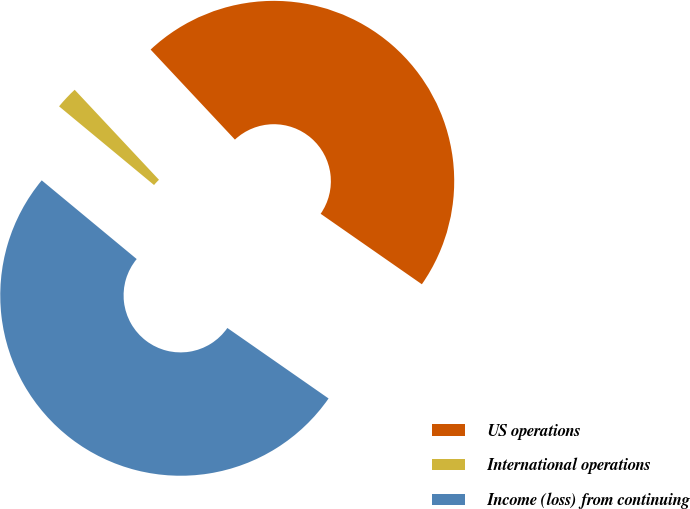<chart> <loc_0><loc_0><loc_500><loc_500><pie_chart><fcel>US operations<fcel>International operations<fcel>Income (loss) from continuing<nl><fcel>46.66%<fcel>2.01%<fcel>51.33%<nl></chart> 